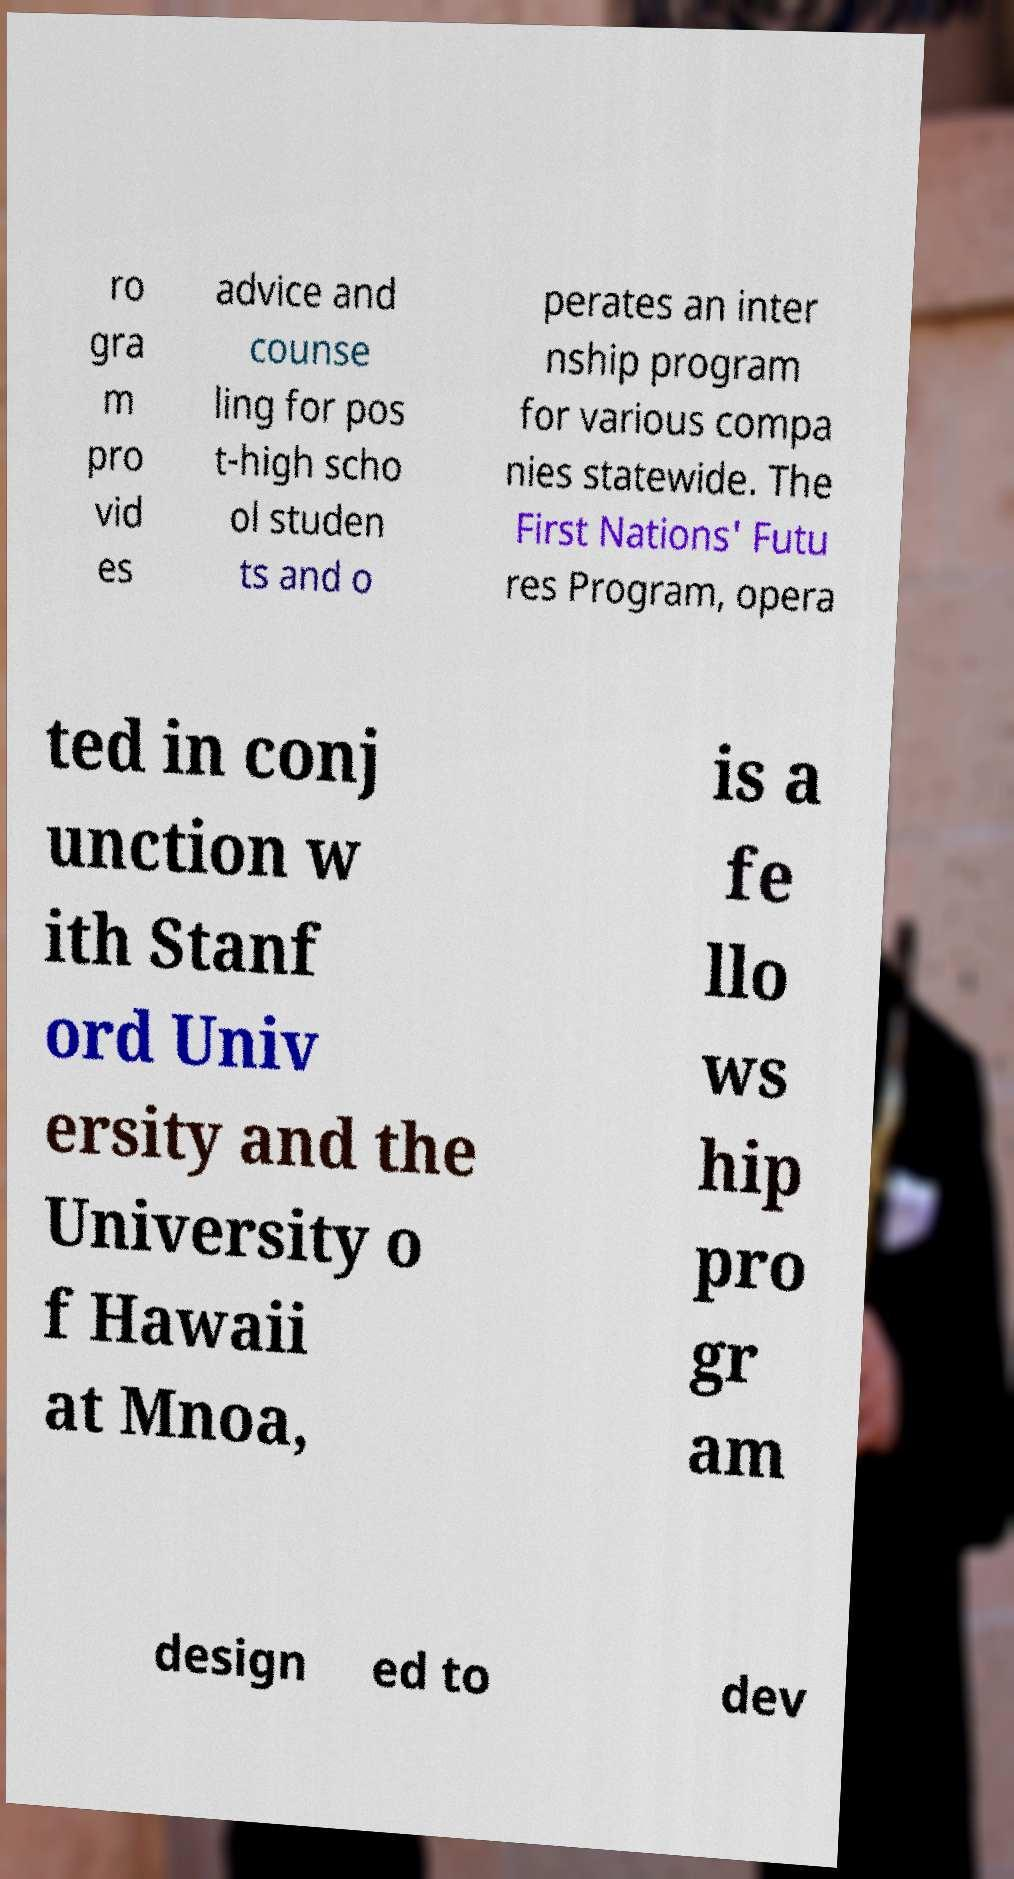Please identify and transcribe the text found in this image. ro gra m pro vid es advice and counse ling for pos t-high scho ol studen ts and o perates an inter nship program for various compa nies statewide. The First Nations' Futu res Program, opera ted in conj unction w ith Stanf ord Univ ersity and the University o f Hawaii at Mnoa, is a fe llo ws hip pro gr am design ed to dev 